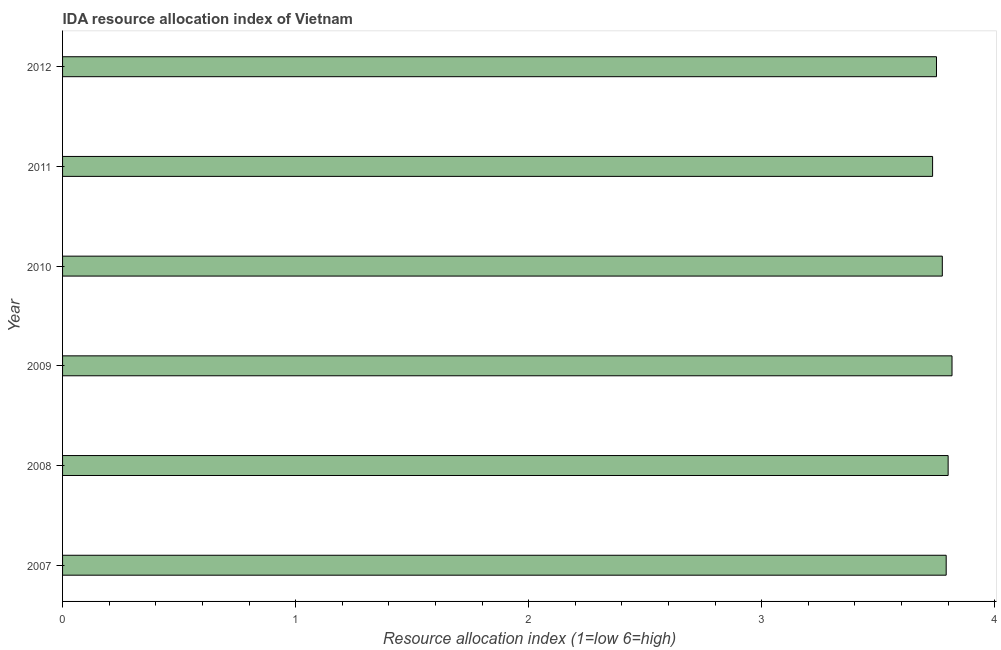Does the graph contain any zero values?
Your response must be concise. No. Does the graph contain grids?
Give a very brief answer. No. What is the title of the graph?
Offer a very short reply. IDA resource allocation index of Vietnam. What is the label or title of the X-axis?
Your answer should be compact. Resource allocation index (1=low 6=high). What is the label or title of the Y-axis?
Offer a terse response. Year. What is the ida resource allocation index in 2012?
Ensure brevity in your answer.  3.75. Across all years, what is the maximum ida resource allocation index?
Ensure brevity in your answer.  3.82. Across all years, what is the minimum ida resource allocation index?
Make the answer very short. 3.73. In which year was the ida resource allocation index maximum?
Make the answer very short. 2009. In which year was the ida resource allocation index minimum?
Provide a succinct answer. 2011. What is the sum of the ida resource allocation index?
Your answer should be very brief. 22.67. What is the difference between the ida resource allocation index in 2007 and 2010?
Your answer should be compact. 0.02. What is the average ida resource allocation index per year?
Offer a very short reply. 3.78. What is the median ida resource allocation index?
Provide a short and direct response. 3.78. In how many years, is the ida resource allocation index greater than 2.8 ?
Ensure brevity in your answer.  6. Do a majority of the years between 2011 and 2010 (inclusive) have ida resource allocation index greater than 2.2 ?
Give a very brief answer. No. Is the ida resource allocation index in 2011 less than that in 2012?
Your answer should be compact. Yes. Is the difference between the ida resource allocation index in 2011 and 2012 greater than the difference between any two years?
Give a very brief answer. No. What is the difference between the highest and the second highest ida resource allocation index?
Give a very brief answer. 0.02. Is the sum of the ida resource allocation index in 2010 and 2012 greater than the maximum ida resource allocation index across all years?
Make the answer very short. Yes. What is the difference between the highest and the lowest ida resource allocation index?
Your answer should be compact. 0.08. In how many years, is the ida resource allocation index greater than the average ida resource allocation index taken over all years?
Offer a very short reply. 3. Are all the bars in the graph horizontal?
Provide a short and direct response. Yes. What is the Resource allocation index (1=low 6=high) of 2007?
Offer a terse response. 3.79. What is the Resource allocation index (1=low 6=high) in 2009?
Your answer should be compact. 3.82. What is the Resource allocation index (1=low 6=high) of 2010?
Offer a very short reply. 3.77. What is the Resource allocation index (1=low 6=high) of 2011?
Your answer should be very brief. 3.73. What is the Resource allocation index (1=low 6=high) of 2012?
Your answer should be compact. 3.75. What is the difference between the Resource allocation index (1=low 6=high) in 2007 and 2008?
Your answer should be very brief. -0.01. What is the difference between the Resource allocation index (1=low 6=high) in 2007 and 2009?
Provide a succinct answer. -0.03. What is the difference between the Resource allocation index (1=low 6=high) in 2007 and 2010?
Provide a succinct answer. 0.02. What is the difference between the Resource allocation index (1=low 6=high) in 2007 and 2011?
Offer a very short reply. 0.06. What is the difference between the Resource allocation index (1=low 6=high) in 2007 and 2012?
Keep it short and to the point. 0.04. What is the difference between the Resource allocation index (1=low 6=high) in 2008 and 2009?
Provide a short and direct response. -0.02. What is the difference between the Resource allocation index (1=low 6=high) in 2008 and 2010?
Offer a very short reply. 0.03. What is the difference between the Resource allocation index (1=low 6=high) in 2008 and 2011?
Provide a short and direct response. 0.07. What is the difference between the Resource allocation index (1=low 6=high) in 2008 and 2012?
Keep it short and to the point. 0.05. What is the difference between the Resource allocation index (1=low 6=high) in 2009 and 2010?
Your answer should be compact. 0.04. What is the difference between the Resource allocation index (1=low 6=high) in 2009 and 2011?
Your response must be concise. 0.08. What is the difference between the Resource allocation index (1=low 6=high) in 2009 and 2012?
Keep it short and to the point. 0.07. What is the difference between the Resource allocation index (1=low 6=high) in 2010 and 2011?
Make the answer very short. 0.04. What is the difference between the Resource allocation index (1=low 6=high) in 2010 and 2012?
Offer a very short reply. 0.03. What is the difference between the Resource allocation index (1=low 6=high) in 2011 and 2012?
Your answer should be very brief. -0.02. What is the ratio of the Resource allocation index (1=low 6=high) in 2007 to that in 2009?
Make the answer very short. 0.99. What is the ratio of the Resource allocation index (1=low 6=high) in 2007 to that in 2011?
Your answer should be very brief. 1.02. What is the ratio of the Resource allocation index (1=low 6=high) in 2007 to that in 2012?
Your answer should be compact. 1.01. What is the ratio of the Resource allocation index (1=low 6=high) in 2008 to that in 2010?
Keep it short and to the point. 1.01. What is the ratio of the Resource allocation index (1=low 6=high) in 2009 to that in 2010?
Your answer should be compact. 1.01. What is the ratio of the Resource allocation index (1=low 6=high) in 2009 to that in 2011?
Your response must be concise. 1.02. What is the ratio of the Resource allocation index (1=low 6=high) in 2010 to that in 2011?
Provide a short and direct response. 1.01. What is the ratio of the Resource allocation index (1=low 6=high) in 2011 to that in 2012?
Keep it short and to the point. 1. 